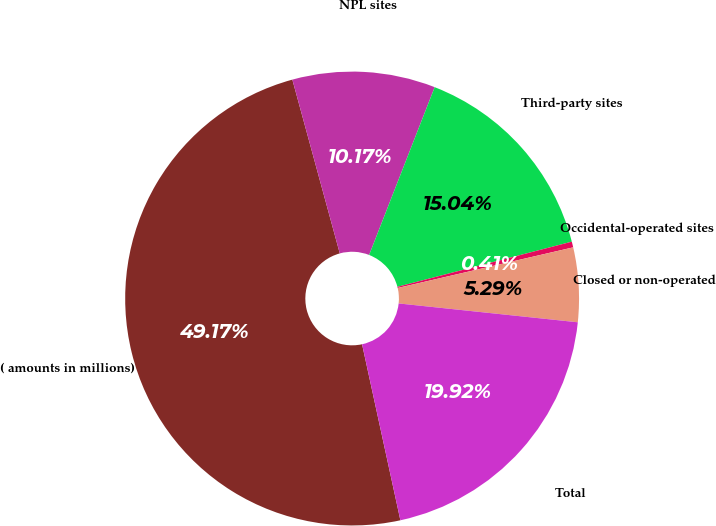Convert chart. <chart><loc_0><loc_0><loc_500><loc_500><pie_chart><fcel>( amounts in millions)<fcel>NPL sites<fcel>Third-party sites<fcel>Occidental-operated sites<fcel>Closed or non-operated<fcel>Total<nl><fcel>49.17%<fcel>10.17%<fcel>15.04%<fcel>0.41%<fcel>5.29%<fcel>19.92%<nl></chart> 